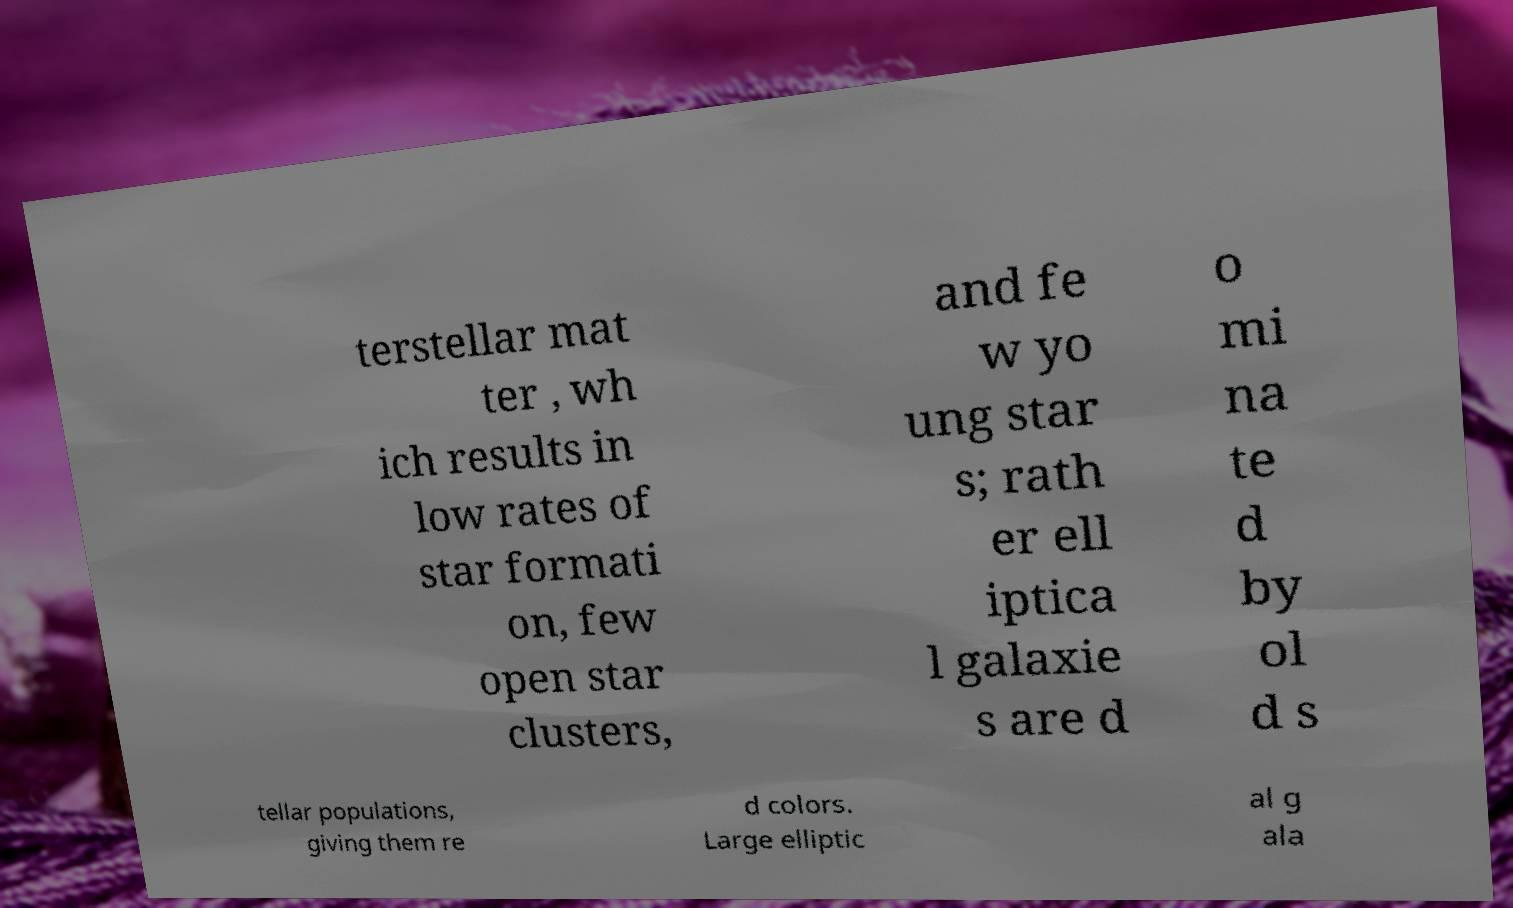Please identify and transcribe the text found in this image. terstellar mat ter , wh ich results in low rates of star formati on, few open star clusters, and fe w yo ung star s; rath er ell iptica l galaxie s are d o mi na te d by ol d s tellar populations, giving them re d colors. Large elliptic al g ala 